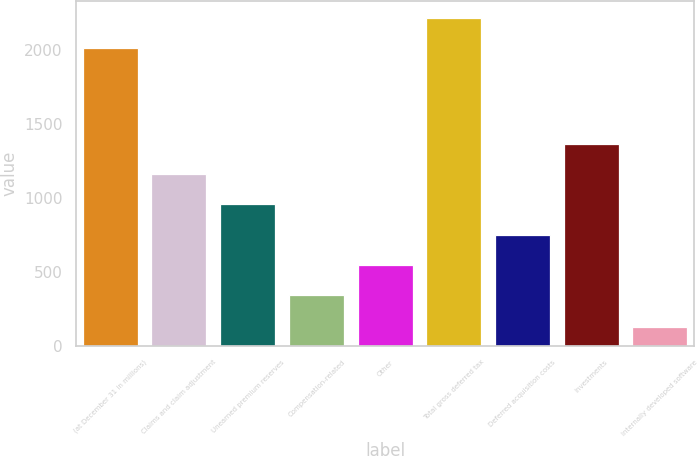Convert chart to OTSL. <chart><loc_0><loc_0><loc_500><loc_500><bar_chart><fcel>(at December 31 in millions)<fcel>Claims and claim adjustment<fcel>Unearned premium reserves<fcel>Compensation-related<fcel>Other<fcel>Total gross deferred tax<fcel>Deferred acquisition costs<fcel>Investments<fcel>Internally developed software<nl><fcel>2014<fcel>1160.2<fcel>956.4<fcel>345<fcel>548.8<fcel>2217.8<fcel>752.6<fcel>1364<fcel>130<nl></chart> 